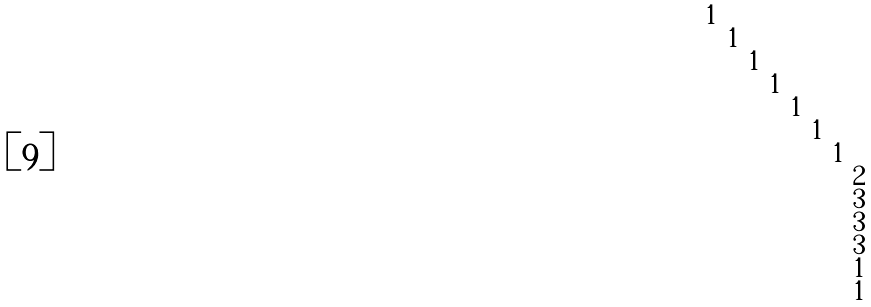<formula> <loc_0><loc_0><loc_500><loc_500>\begin{smallmatrix} 1 & & & & & & & \\ & 1 & & & & & & \\ & & 1 & & & & & \\ & & & 1 & & & & \\ & & & & 1 & & & \\ & & & & & 1 & & \\ & & & & & & 1 & \\ & & & & & & & 2 \\ & & & & & & & 3 \\ & & & & & & & 3 \\ & & & & & & & 3 \\ & & & & & & & 1 \\ & & & & & & & 1 \\ \end{smallmatrix}</formula> 